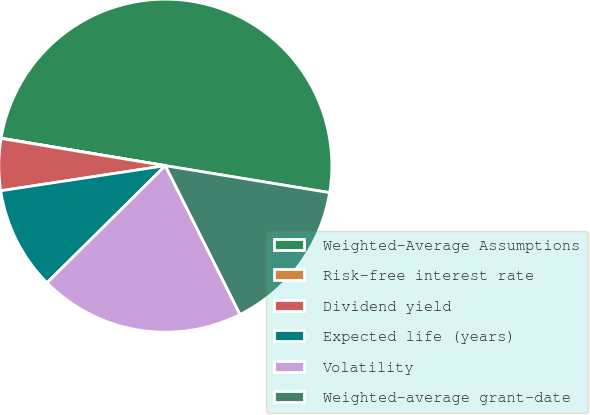<chart> <loc_0><loc_0><loc_500><loc_500><pie_chart><fcel>Weighted-Average Assumptions<fcel>Risk-free interest rate<fcel>Dividend yield<fcel>Expected life (years)<fcel>Volatility<fcel>Weighted-average grant-date<nl><fcel>49.94%<fcel>0.03%<fcel>5.02%<fcel>10.01%<fcel>19.99%<fcel>15.0%<nl></chart> 